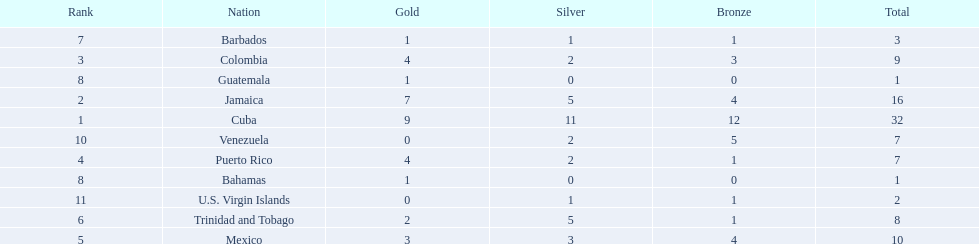Who had more silvers? colmbia or the bahamas Colombia. 